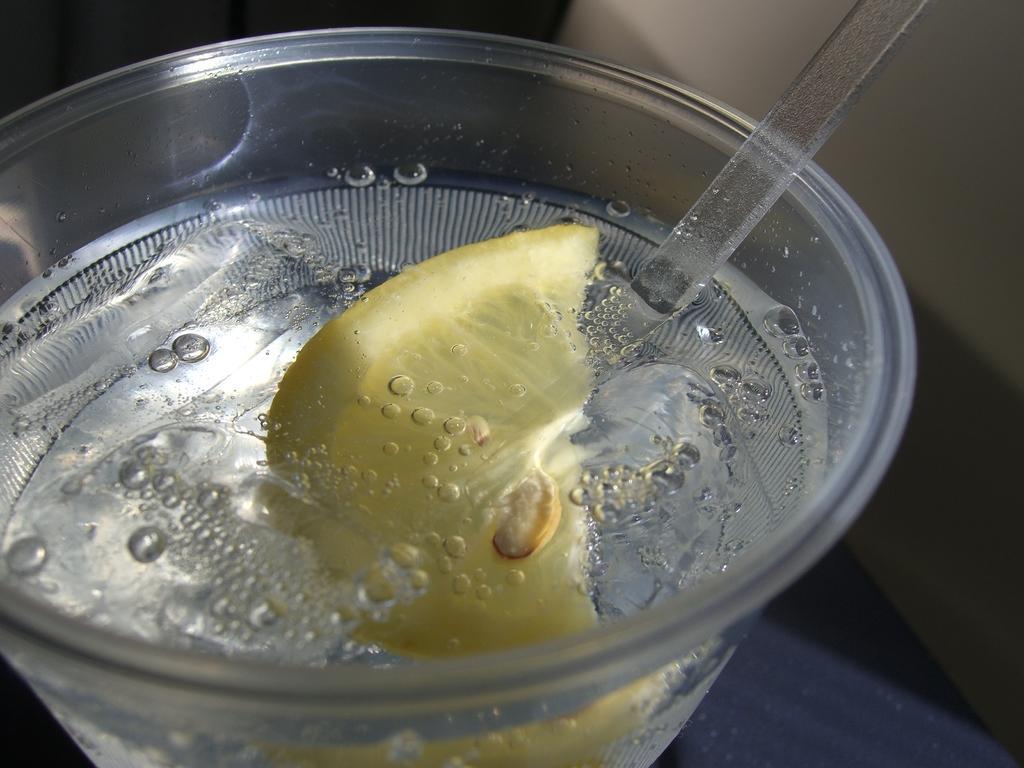In one or two sentences, can you explain what this image depicts? In this picture I can see a bowl and I can see a yellow color thing and I can see a thing, which looks like a straw on the right side of this image. I see that it is a bit dark in the background. 